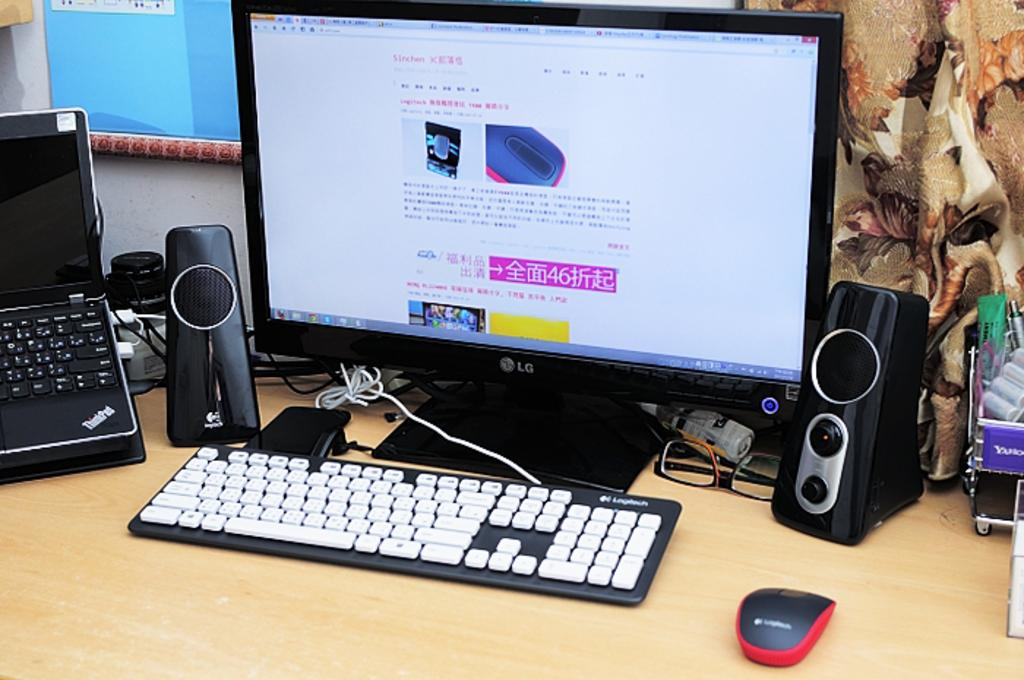Provide a one-sentence caption for the provided image. Computer from LG with keyboard, speaker, and mouse. 